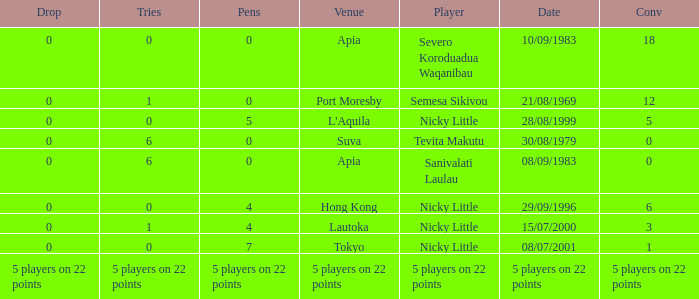How many drops did Nicky Little have in Hong Kong? 0.0. 